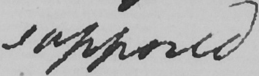What text is written in this handwritten line? supposed 